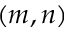<formula> <loc_0><loc_0><loc_500><loc_500>( m , n )</formula> 